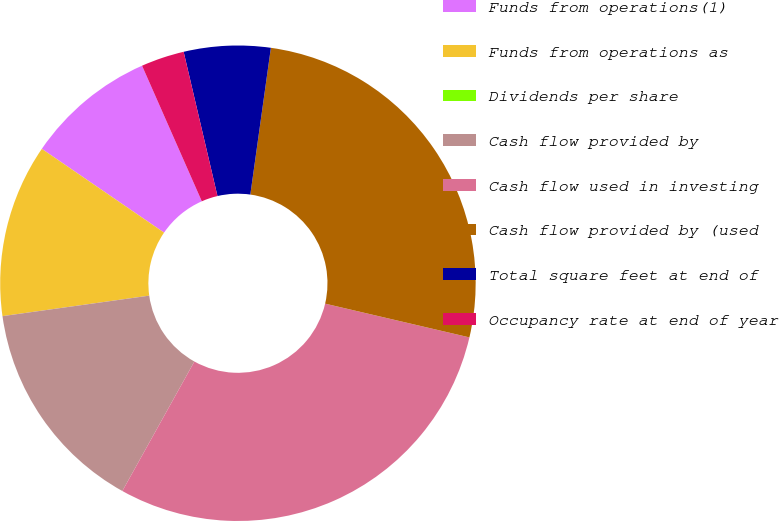Convert chart to OTSL. <chart><loc_0><loc_0><loc_500><loc_500><pie_chart><fcel>Funds from operations(1)<fcel>Funds from operations as<fcel>Dividends per share<fcel>Cash flow provided by<fcel>Cash flow used in investing<fcel>Cash flow provided by (used<fcel>Total square feet at end of<fcel>Occupancy rate at end of year<nl><fcel>8.83%<fcel>11.77%<fcel>0.0%<fcel>14.71%<fcel>29.42%<fcel>26.44%<fcel>5.88%<fcel>2.94%<nl></chart> 